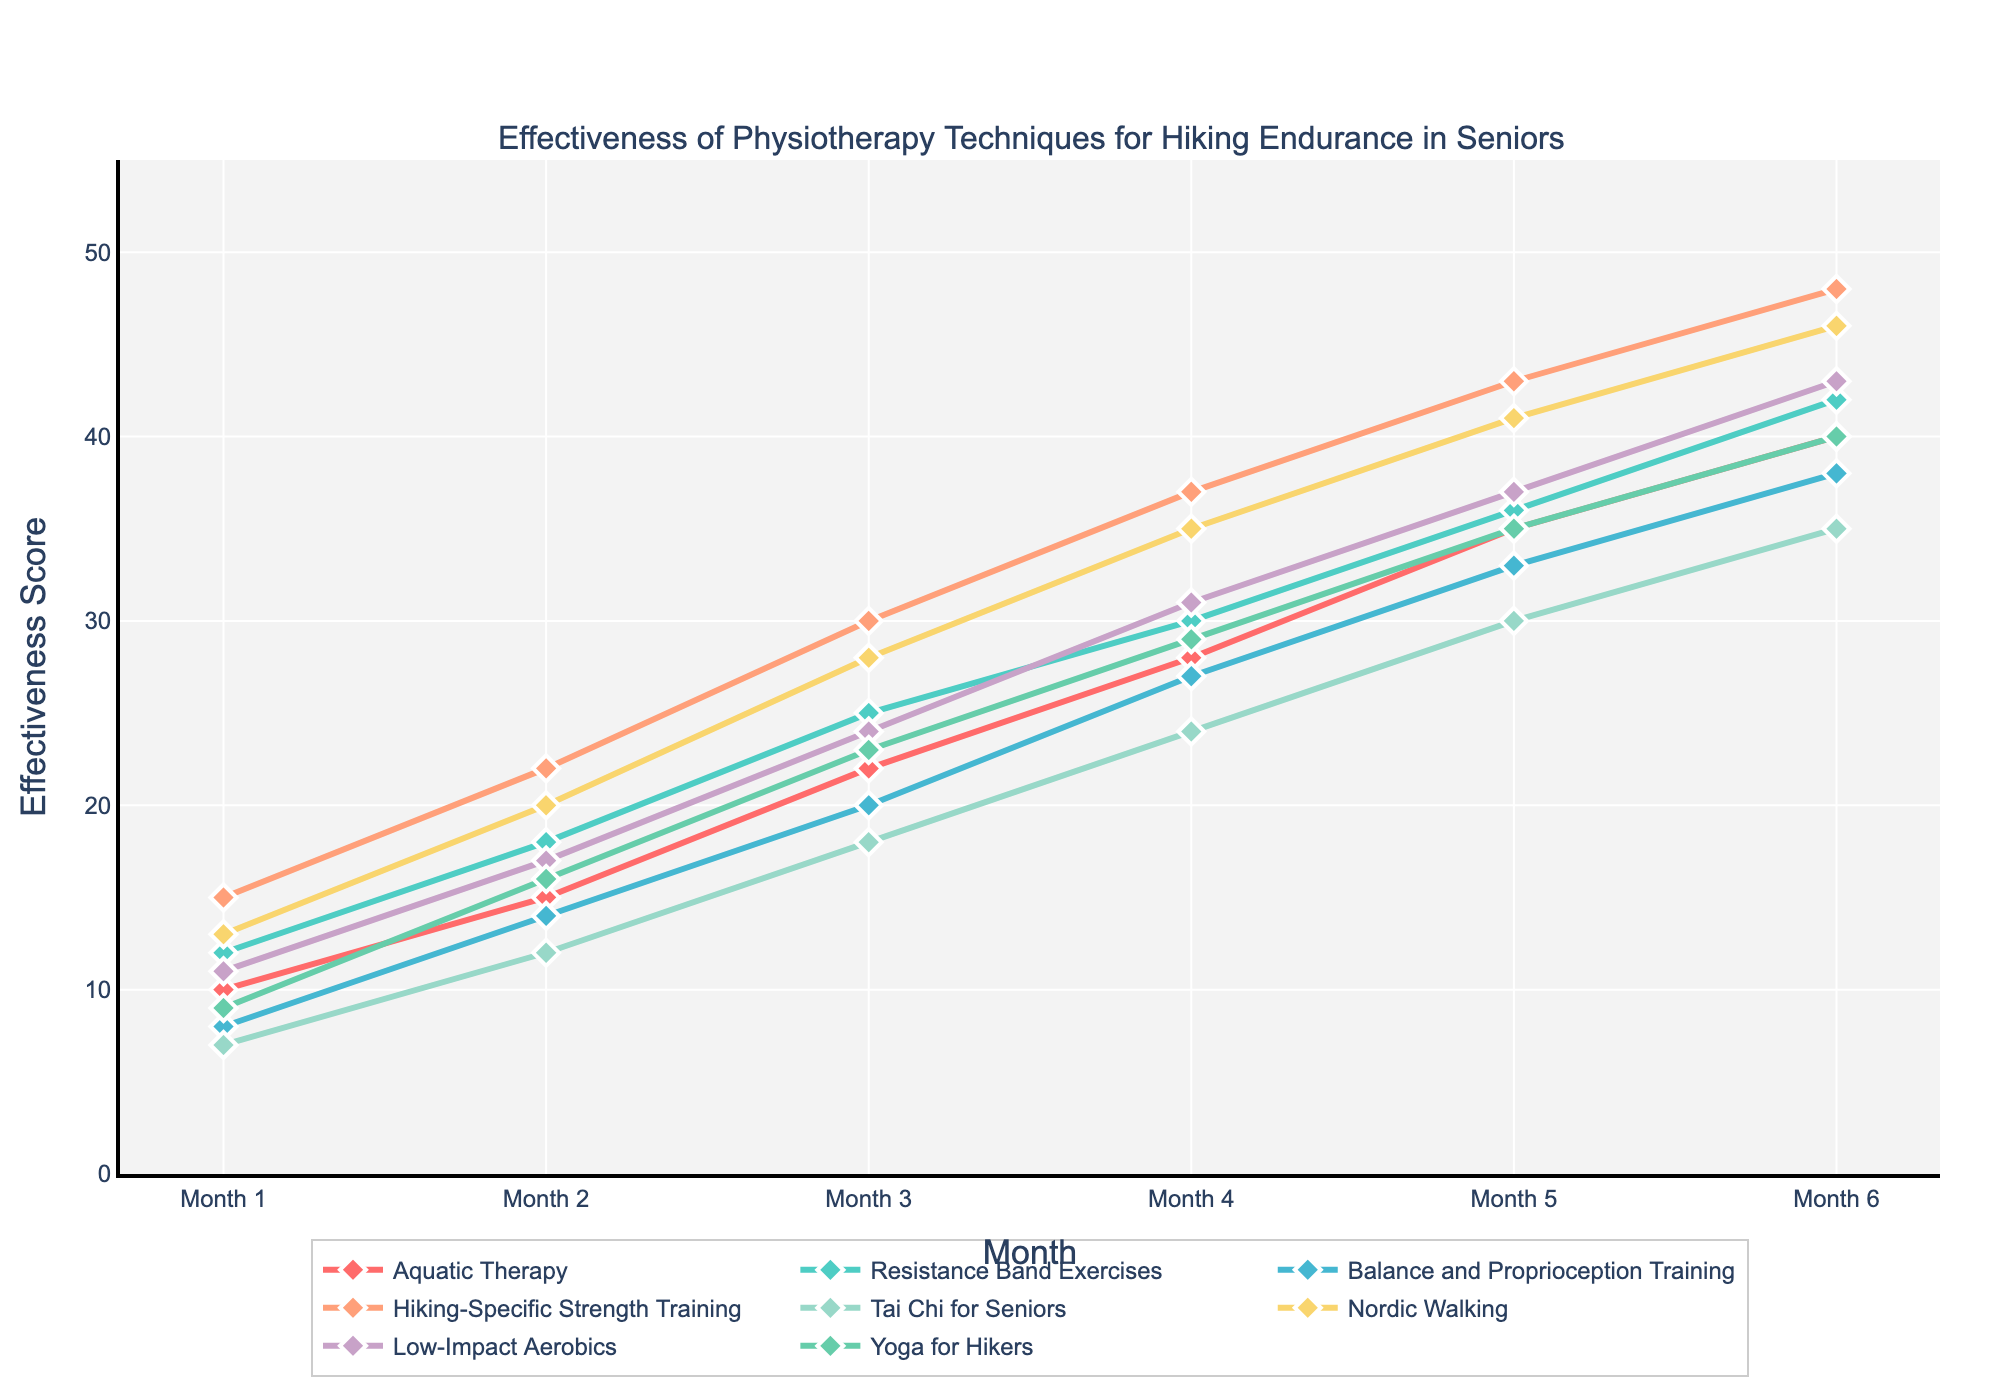What technique shows the most improvement from Month 1 to Month 6? Hiking-Specific Strength Training starts at 15 in Month 1 and reaches 48 by Month 6. The improvement is 48 - 15 = 33. This is the highest improvement among all techniques.
Answer: Hiking-Specific Strength Training How does the effectiveness score of Nordic Walking change from Month 1 to Month 4? The effectiveness score starts at 13 in Month 1 and reaches 35 by Month 4. The change is 35 - 13 = 22.
Answer: 22 Which two techniques have the same effectiveness score in Month 6? In Month 6, Aquatic Therapy and Yoga for Hikers both have a score of 40.
Answer: Aquatic Therapy and Yoga for Hikers Which technique has the second highest score in Month 5? In Month 5, the scores are Hiking-Specific Strength Training (43), Nordic Walking (41), Low-Impact Aerobics (37), Resistance Band Exercises (36), Aquatic Therapy (35), Yoga for Hikers (35), Tai Chi for Seniors (30), and Balance and Proprioception Training (33). The second highest score is Nordic Walking at 41.
Answer: Nordic Walking What is the average effectiveness score of Tai Chi for Seniors over the 6 months? Sum the scores for Tai Chi for Seniors (7 + 12 + 18 + 24 + 30 + 35) = 126 and divide by the number of months (6). The average is 126 / 6 = 21.
Answer: 21 Compare the improvement of Balance and Proprioception Training and Low-Impact Aerobics over the 6 months. Balance and Proprioception Training starts at 8 and ends at 38, so the improvement is 38 - 8 = 30. Low-Impact Aerobics starts at 11 and ends at 43, so the improvement is 43 - 11 = 32. Low-Impact Aerobics has a greater improvement.
Answer: Low-Impact Aerobics What is the total effectiveness score of Resistance Band Exercises across all months? Sum the scores over the 6 months for Resistance Band Exercises (12 + 18 + 25 + 30 + 36 + 42). The total is 12 + 18 + 25 + 30 + 36 + 42 = 163.
Answer: 163 Between Month 3 and Month 4, which technique shows the highest increase in effectiveness? Hiking-Specific Strength Training increases from 30 to 37 (a change of 7), which is the highest increase seen across all techniques between these two months.
Answer: Hiking-Specific Strength Training 